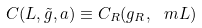<formula> <loc_0><loc_0><loc_500><loc_500>C ( L , \tilde { g } , a ) \equiv C _ { R } ( g _ { R } , \ m L )</formula> 